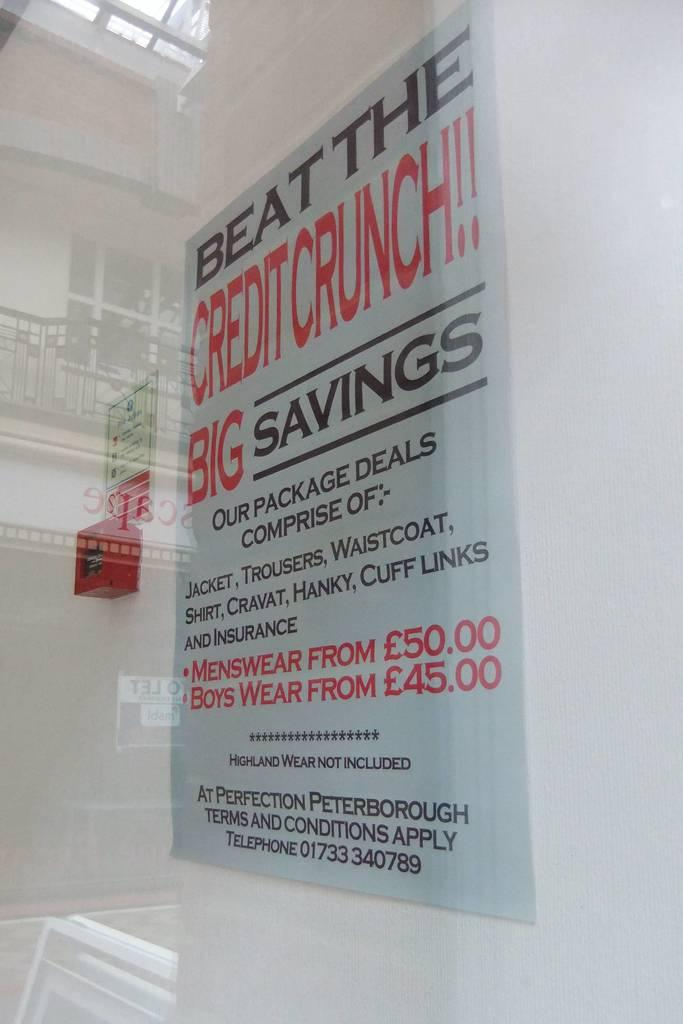<image>
Provide a brief description of the given image. A poster on a wall wants people to beat the credit crunch and get big savings. 